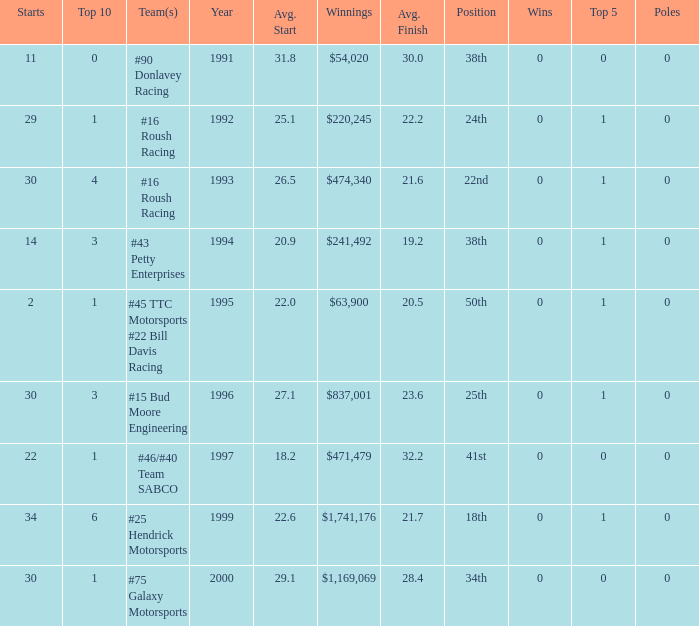What the rank in the top 10 when the  winnings were $1,741,176? 6.0. Could you help me parse every detail presented in this table? {'header': ['Starts', 'Top 10', 'Team(s)', 'Year', 'Avg. Start', 'Winnings', 'Avg. Finish', 'Position', 'Wins', 'Top 5', 'Poles'], 'rows': [['11', '0', '#90 Donlavey Racing', '1991', '31.8', '$54,020', '30.0', '38th', '0', '0', '0'], ['29', '1', '#16 Roush Racing', '1992', '25.1', '$220,245', '22.2', '24th', '0', '1', '0'], ['30', '4', '#16 Roush Racing', '1993', '26.5', '$474,340', '21.6', '22nd', '0', '1', '0'], ['14', '3', '#43 Petty Enterprises', '1994', '20.9', '$241,492', '19.2', '38th', '0', '1', '0'], ['2', '1', '#45 TTC Motorsports #22 Bill Davis Racing', '1995', '22.0', '$63,900', '20.5', '50th', '0', '1', '0'], ['30', '3', '#15 Bud Moore Engineering', '1996', '27.1', '$837,001', '23.6', '25th', '0', '1', '0'], ['22', '1', '#46/#40 Team SABCO', '1997', '18.2', '$471,479', '32.2', '41st', '0', '0', '0'], ['34', '6', '#25 Hendrick Motorsports', '1999', '22.6', '$1,741,176', '21.7', '18th', '0', '1', '0'], ['30', '1', '#75 Galaxy Motorsports', '2000', '29.1', '$1,169,069', '28.4', '34th', '0', '0', '0']]} 